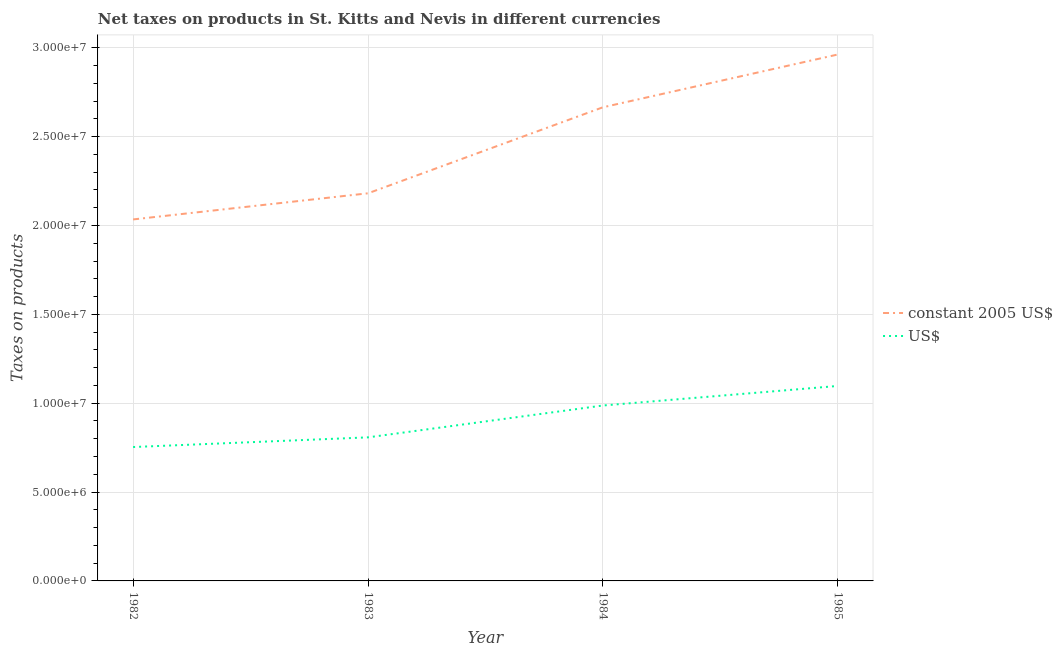Is the number of lines equal to the number of legend labels?
Your response must be concise. Yes. What is the net taxes in constant 2005 us$ in 1982?
Your response must be concise. 2.03e+07. Across all years, what is the maximum net taxes in us$?
Your answer should be compact. 1.10e+07. Across all years, what is the minimum net taxes in constant 2005 us$?
Make the answer very short. 2.03e+07. In which year was the net taxes in us$ minimum?
Keep it short and to the point. 1982. What is the total net taxes in constant 2005 us$ in the graph?
Make the answer very short. 9.84e+07. What is the difference between the net taxes in us$ in 1984 and that in 1985?
Keep it short and to the point. -1.10e+06. What is the difference between the net taxes in us$ in 1984 and the net taxes in constant 2005 us$ in 1985?
Offer a very short reply. -1.97e+07. What is the average net taxes in us$ per year?
Your answer should be compact. 9.11e+06. In the year 1984, what is the difference between the net taxes in constant 2005 us$ and net taxes in us$?
Provide a short and direct response. 1.68e+07. What is the ratio of the net taxes in constant 2005 us$ in 1984 to that in 1985?
Your answer should be very brief. 0.9. Is the net taxes in us$ in 1984 less than that in 1985?
Give a very brief answer. Yes. What is the difference between the highest and the second highest net taxes in constant 2005 us$?
Make the answer very short. 2.97e+06. What is the difference between the highest and the lowest net taxes in us$?
Ensure brevity in your answer.  3.44e+06. Is the net taxes in us$ strictly greater than the net taxes in constant 2005 us$ over the years?
Your answer should be compact. No. Is the net taxes in constant 2005 us$ strictly less than the net taxes in us$ over the years?
Your answer should be compact. No. How many lines are there?
Your answer should be very brief. 2. What is the difference between two consecutive major ticks on the Y-axis?
Provide a succinct answer. 5.00e+06. Are the values on the major ticks of Y-axis written in scientific E-notation?
Keep it short and to the point. Yes. Does the graph contain any zero values?
Your answer should be compact. No. How are the legend labels stacked?
Keep it short and to the point. Vertical. What is the title of the graph?
Give a very brief answer. Net taxes on products in St. Kitts and Nevis in different currencies. What is the label or title of the X-axis?
Provide a short and direct response. Year. What is the label or title of the Y-axis?
Offer a terse response. Taxes on products. What is the Taxes on products in constant 2005 US$ in 1982?
Make the answer very short. 2.03e+07. What is the Taxes on products of US$ in 1982?
Keep it short and to the point. 7.53e+06. What is the Taxes on products in constant 2005 US$ in 1983?
Provide a short and direct response. 2.18e+07. What is the Taxes on products of US$ in 1983?
Your answer should be very brief. 8.08e+06. What is the Taxes on products in constant 2005 US$ in 1984?
Your answer should be compact. 2.66e+07. What is the Taxes on products in US$ in 1984?
Provide a succinct answer. 9.87e+06. What is the Taxes on products in constant 2005 US$ in 1985?
Offer a very short reply. 2.96e+07. What is the Taxes on products of US$ in 1985?
Make the answer very short. 1.10e+07. Across all years, what is the maximum Taxes on products of constant 2005 US$?
Keep it short and to the point. 2.96e+07. Across all years, what is the maximum Taxes on products of US$?
Provide a succinct answer. 1.10e+07. Across all years, what is the minimum Taxes on products of constant 2005 US$?
Your response must be concise. 2.03e+07. Across all years, what is the minimum Taxes on products in US$?
Keep it short and to the point. 7.53e+06. What is the total Taxes on products in constant 2005 US$ in the graph?
Provide a succinct answer. 9.84e+07. What is the total Taxes on products of US$ in the graph?
Offer a very short reply. 3.65e+07. What is the difference between the Taxes on products of constant 2005 US$ in 1982 and that in 1983?
Your answer should be compact. -1.47e+06. What is the difference between the Taxes on products in US$ in 1982 and that in 1983?
Give a very brief answer. -5.44e+05. What is the difference between the Taxes on products of constant 2005 US$ in 1982 and that in 1984?
Provide a short and direct response. -6.31e+06. What is the difference between the Taxes on products of US$ in 1982 and that in 1984?
Give a very brief answer. -2.34e+06. What is the difference between the Taxes on products of constant 2005 US$ in 1982 and that in 1985?
Keep it short and to the point. -9.28e+06. What is the difference between the Taxes on products of US$ in 1982 and that in 1985?
Make the answer very short. -3.44e+06. What is the difference between the Taxes on products in constant 2005 US$ in 1983 and that in 1984?
Your answer should be very brief. -4.84e+06. What is the difference between the Taxes on products in US$ in 1983 and that in 1984?
Your answer should be very brief. -1.79e+06. What is the difference between the Taxes on products in constant 2005 US$ in 1983 and that in 1985?
Provide a short and direct response. -7.81e+06. What is the difference between the Taxes on products in US$ in 1983 and that in 1985?
Offer a terse response. -2.89e+06. What is the difference between the Taxes on products of constant 2005 US$ in 1984 and that in 1985?
Your answer should be very brief. -2.97e+06. What is the difference between the Taxes on products in US$ in 1984 and that in 1985?
Your answer should be very brief. -1.10e+06. What is the difference between the Taxes on products in constant 2005 US$ in 1982 and the Taxes on products in US$ in 1983?
Make the answer very short. 1.23e+07. What is the difference between the Taxes on products in constant 2005 US$ in 1982 and the Taxes on products in US$ in 1984?
Offer a terse response. 1.05e+07. What is the difference between the Taxes on products of constant 2005 US$ in 1982 and the Taxes on products of US$ in 1985?
Provide a succinct answer. 9.37e+06. What is the difference between the Taxes on products of constant 2005 US$ in 1983 and the Taxes on products of US$ in 1984?
Make the answer very short. 1.19e+07. What is the difference between the Taxes on products of constant 2005 US$ in 1983 and the Taxes on products of US$ in 1985?
Ensure brevity in your answer.  1.08e+07. What is the difference between the Taxes on products in constant 2005 US$ in 1984 and the Taxes on products in US$ in 1985?
Make the answer very short. 1.57e+07. What is the average Taxes on products in constant 2005 US$ per year?
Make the answer very short. 2.46e+07. What is the average Taxes on products of US$ per year?
Provide a succinct answer. 9.11e+06. In the year 1982, what is the difference between the Taxes on products of constant 2005 US$ and Taxes on products of US$?
Your answer should be very brief. 1.28e+07. In the year 1983, what is the difference between the Taxes on products in constant 2005 US$ and Taxes on products in US$?
Make the answer very short. 1.37e+07. In the year 1984, what is the difference between the Taxes on products in constant 2005 US$ and Taxes on products in US$?
Provide a short and direct response. 1.68e+07. In the year 1985, what is the difference between the Taxes on products of constant 2005 US$ and Taxes on products of US$?
Give a very brief answer. 1.86e+07. What is the ratio of the Taxes on products in constant 2005 US$ in 1982 to that in 1983?
Offer a very short reply. 0.93. What is the ratio of the Taxes on products in US$ in 1982 to that in 1983?
Keep it short and to the point. 0.93. What is the ratio of the Taxes on products of constant 2005 US$ in 1982 to that in 1984?
Give a very brief answer. 0.76. What is the ratio of the Taxes on products of US$ in 1982 to that in 1984?
Offer a very short reply. 0.76. What is the ratio of the Taxes on products in constant 2005 US$ in 1982 to that in 1985?
Give a very brief answer. 0.69. What is the ratio of the Taxes on products of US$ in 1982 to that in 1985?
Offer a terse response. 0.69. What is the ratio of the Taxes on products of constant 2005 US$ in 1983 to that in 1984?
Your answer should be very brief. 0.82. What is the ratio of the Taxes on products of US$ in 1983 to that in 1984?
Provide a short and direct response. 0.82. What is the ratio of the Taxes on products in constant 2005 US$ in 1983 to that in 1985?
Make the answer very short. 0.74. What is the ratio of the Taxes on products of US$ in 1983 to that in 1985?
Give a very brief answer. 0.74. What is the ratio of the Taxes on products of constant 2005 US$ in 1984 to that in 1985?
Offer a very short reply. 0.9. What is the ratio of the Taxes on products of US$ in 1984 to that in 1985?
Provide a succinct answer. 0.9. What is the difference between the highest and the second highest Taxes on products in constant 2005 US$?
Your response must be concise. 2.97e+06. What is the difference between the highest and the second highest Taxes on products in US$?
Your response must be concise. 1.10e+06. What is the difference between the highest and the lowest Taxes on products of constant 2005 US$?
Provide a succinct answer. 9.28e+06. What is the difference between the highest and the lowest Taxes on products in US$?
Keep it short and to the point. 3.44e+06. 